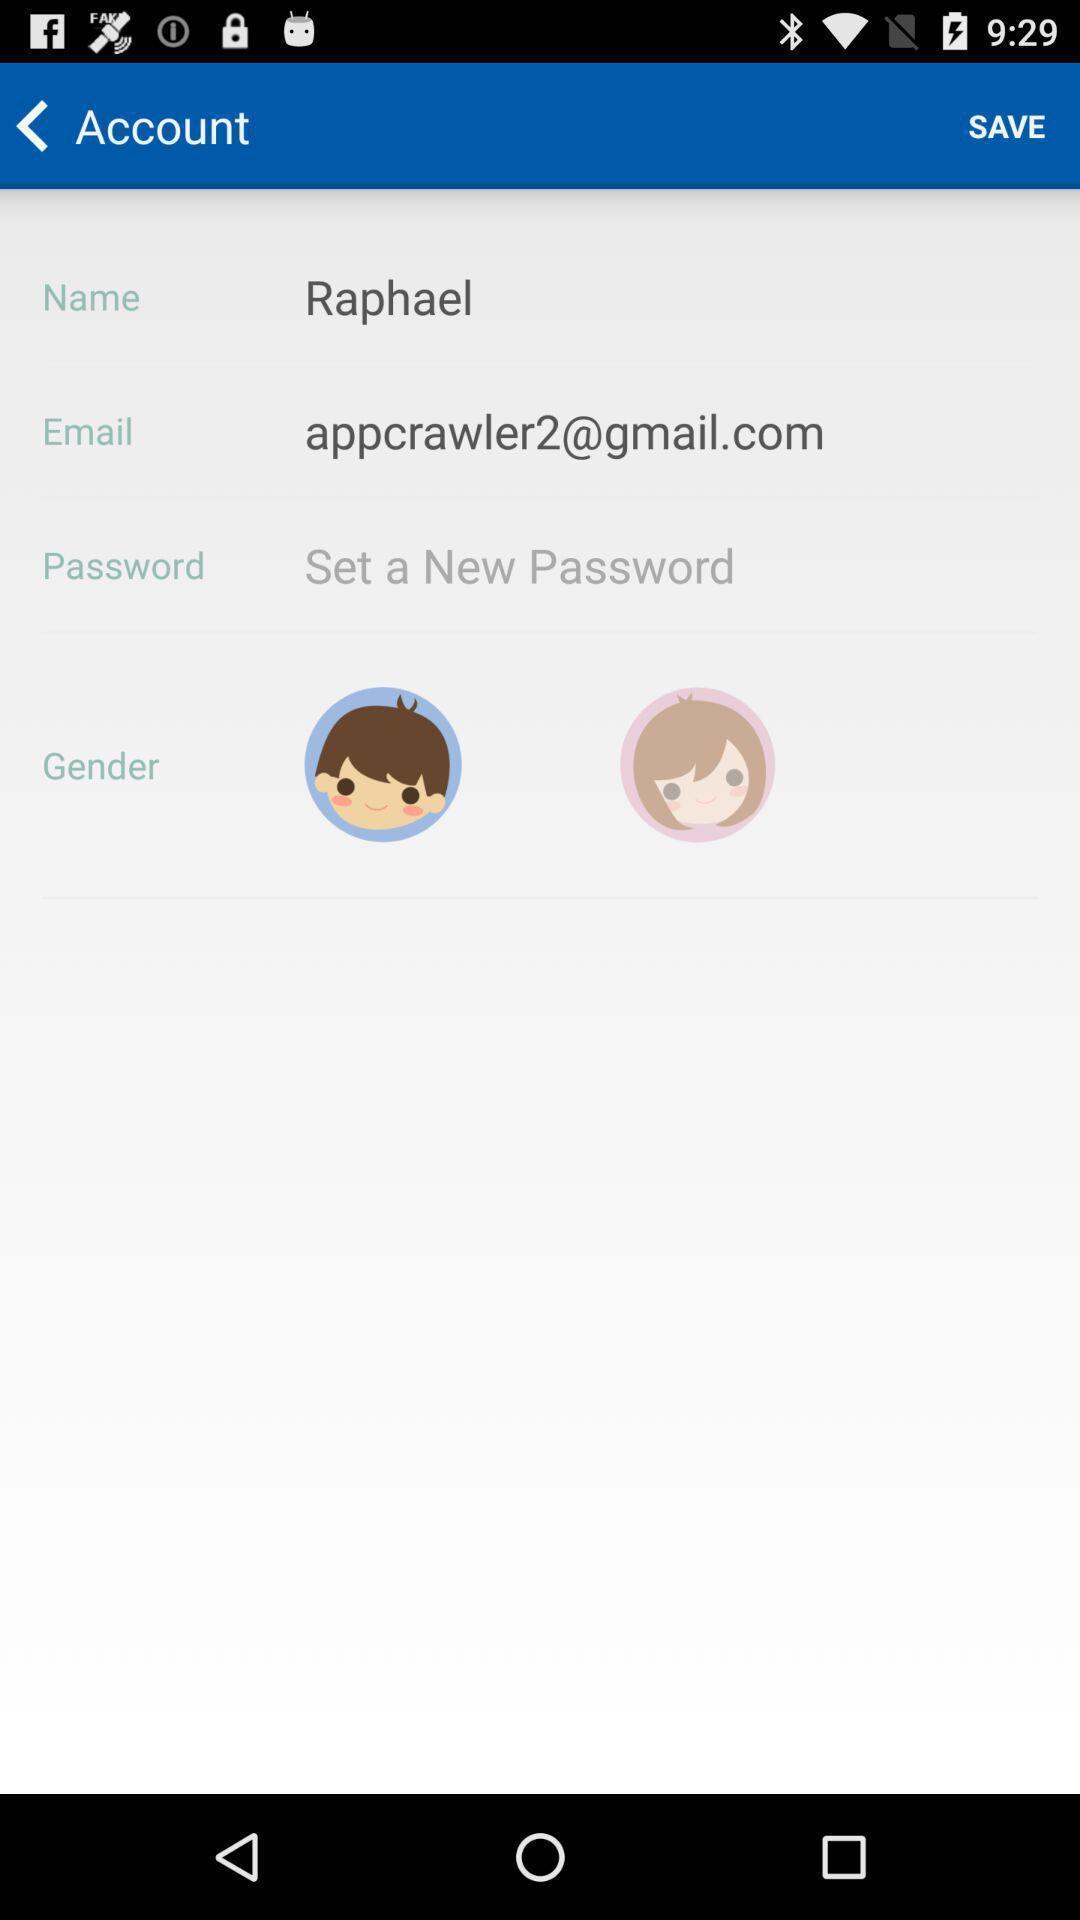Describe the content in this image. Screen displaying account information. 